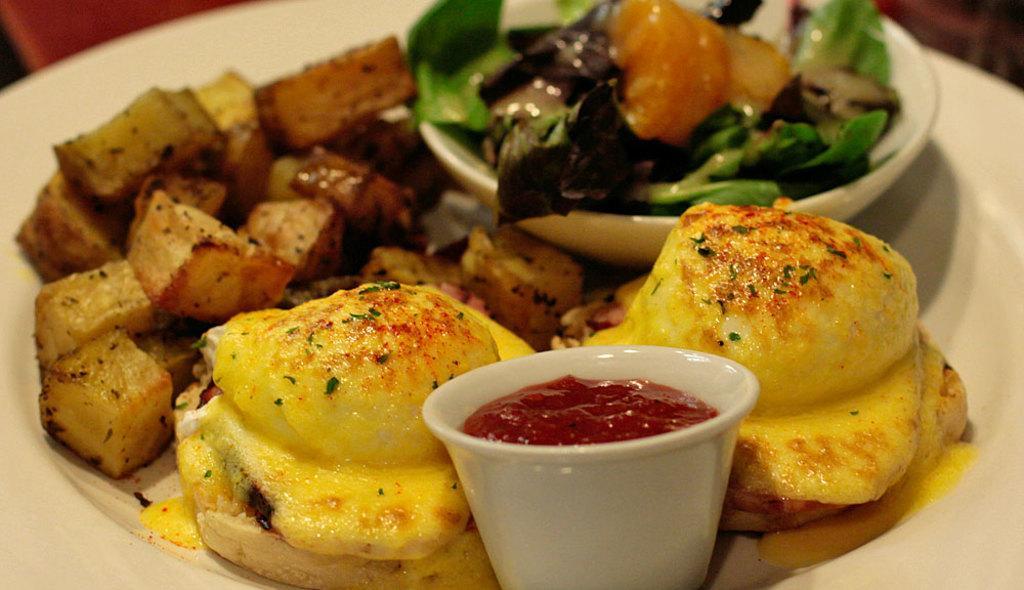Can you describe this image briefly? In this picture I can see food items and cups on white color plate. 